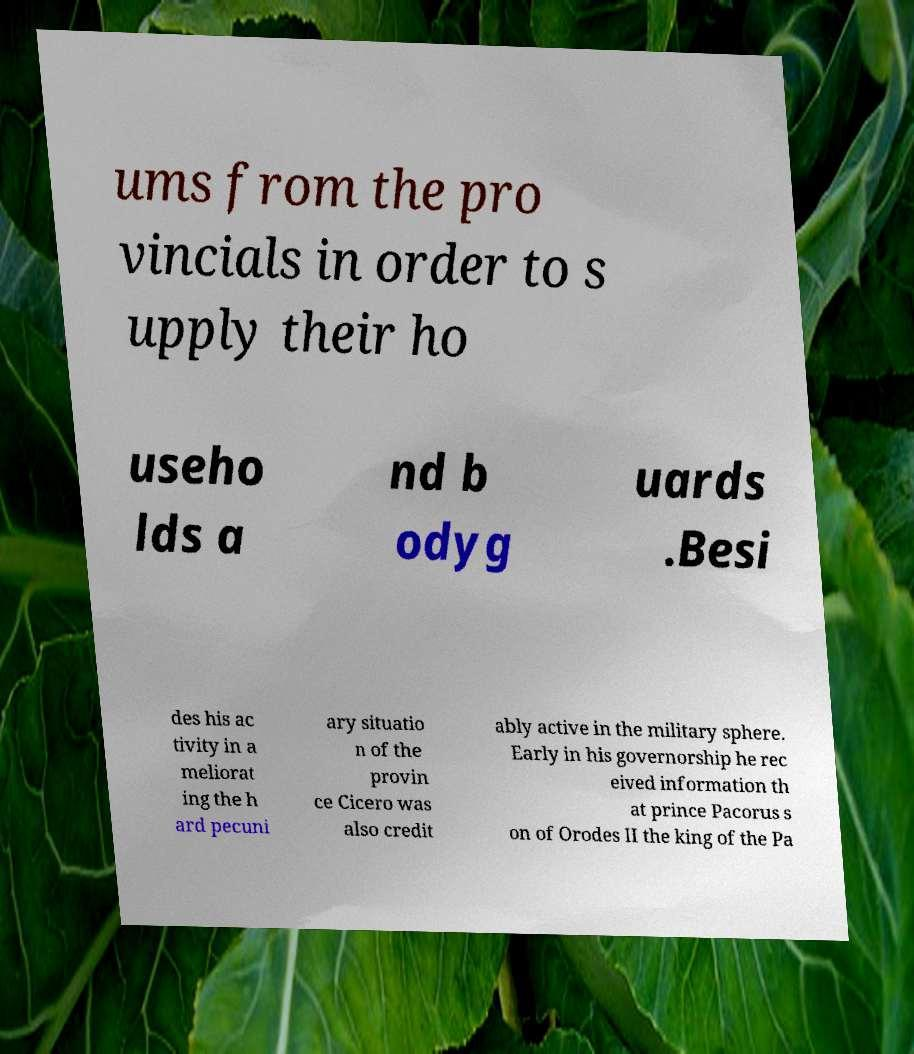Please read and relay the text visible in this image. What does it say? ums from the pro vincials in order to s upply their ho useho lds a nd b odyg uards .Besi des his ac tivity in a meliorat ing the h ard pecuni ary situatio n of the provin ce Cicero was also credit ably active in the military sphere. Early in his governorship he rec eived information th at prince Pacorus s on of Orodes II the king of the Pa 